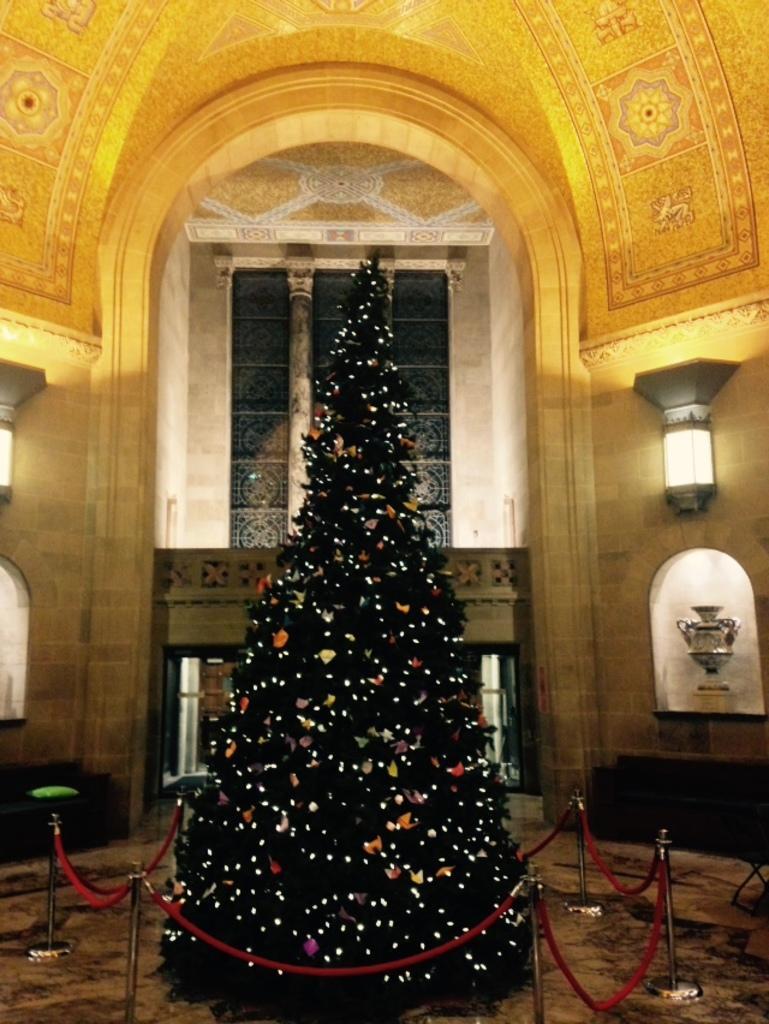Can you describe this image briefly? In this picture, we can see tree with lights, and we can see ground, poles, wall with lights, pillar, and some objects attached to it, we can see designed roof. 